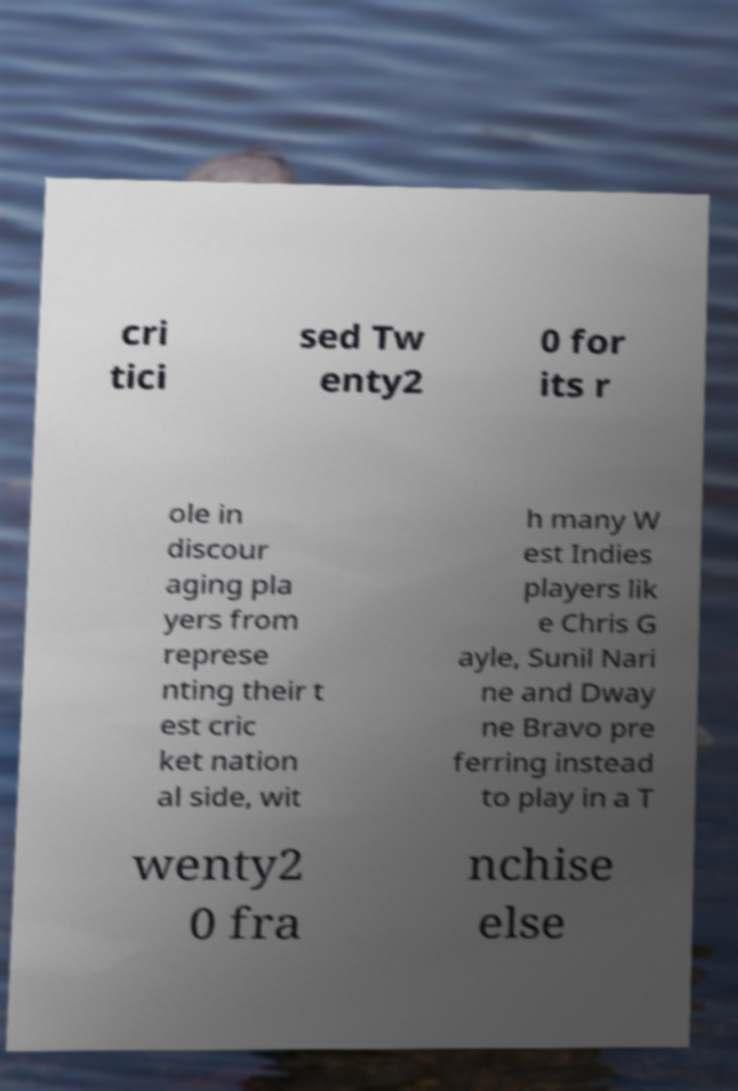Can you read and provide the text displayed in the image?This photo seems to have some interesting text. Can you extract and type it out for me? cri tici sed Tw enty2 0 for its r ole in discour aging pla yers from represe nting their t est cric ket nation al side, wit h many W est Indies players lik e Chris G ayle, Sunil Nari ne and Dway ne Bravo pre ferring instead to play in a T wenty2 0 fra nchise else 